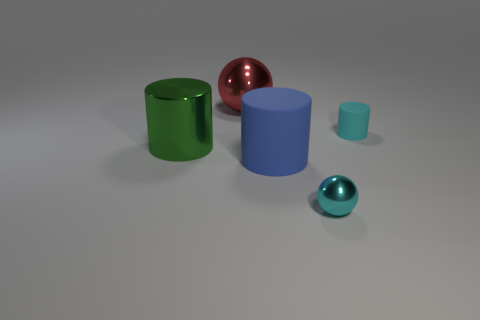What can we infer about the size of objects relative to each other? The relative sizes of the objects seem to follow a descending order from left to right. The green cylinder is the tallest among the cylinders, while the blue sphere appears to be the largest spherical object. The sizes can be inferred by comparing their dimensions and the way they overlap each other and cast shadows on the ground. 